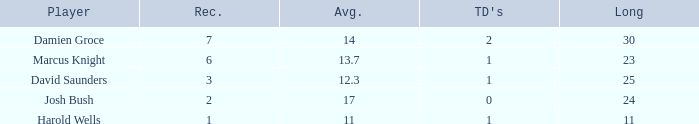How many TDs are there were the long is smaller than 23? 1.0. Parse the table in full. {'header': ['Player', 'Rec.', 'Avg.', "TD's", 'Long'], 'rows': [['Damien Groce', '7', '14', '2', '30'], ['Marcus Knight', '6', '13.7', '1', '23'], ['David Saunders', '3', '12.3', '1', '25'], ['Josh Bush', '2', '17', '0', '24'], ['Harold Wells', '1', '11', '1', '11']]} 